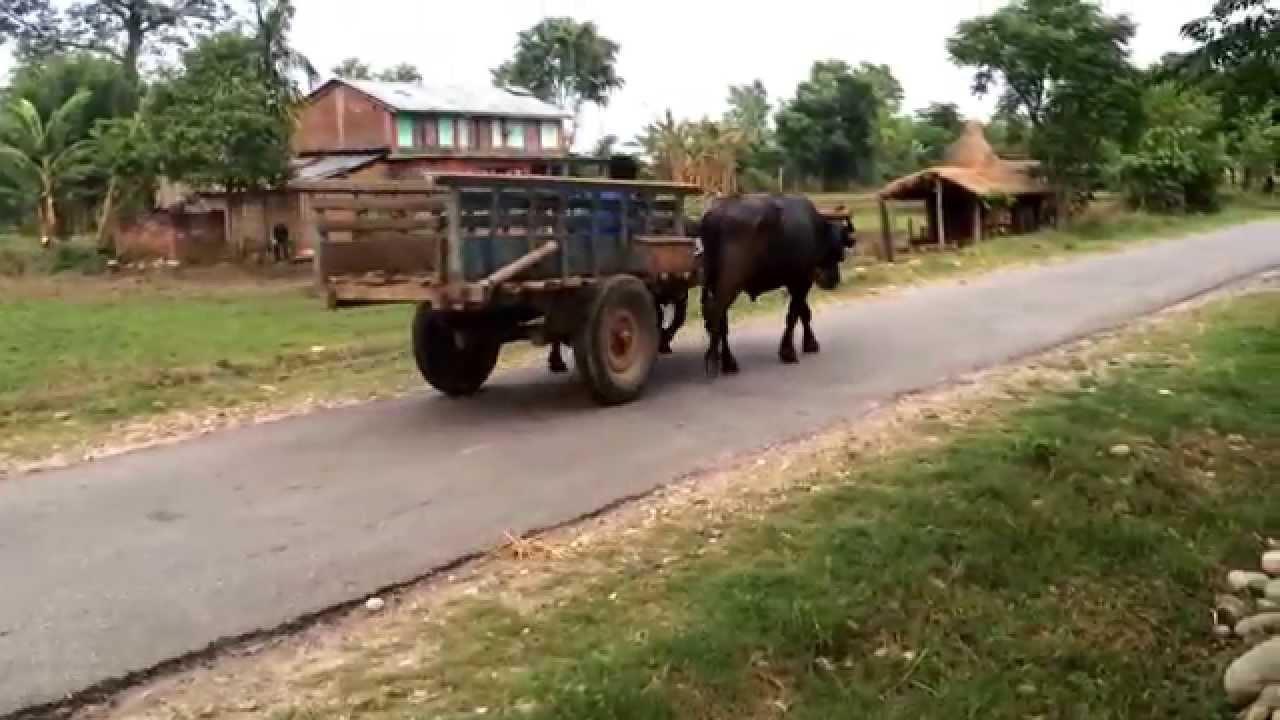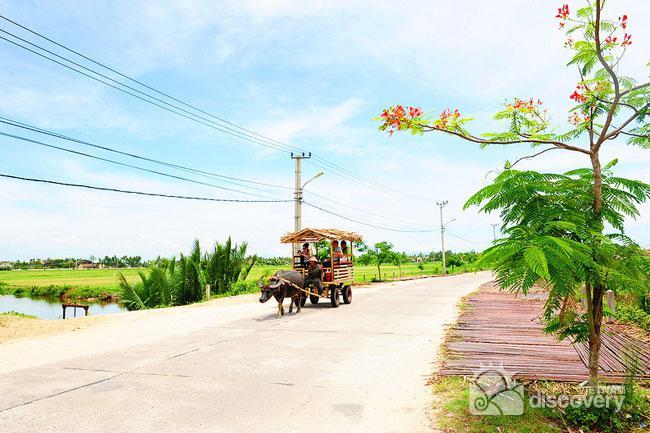The first image is the image on the left, the second image is the image on the right. Analyze the images presented: Is the assertion "In the left image, two oxen are yolked to the cart." valid? Answer yes or no. No. The first image is the image on the left, the second image is the image on the right. Examine the images to the left and right. Is the description "One image shows an ox pulling a cart with a thatched roof over passengers, and the other image shows at least one dark ox pulling a cart without a roof." accurate? Answer yes or no. Yes. 